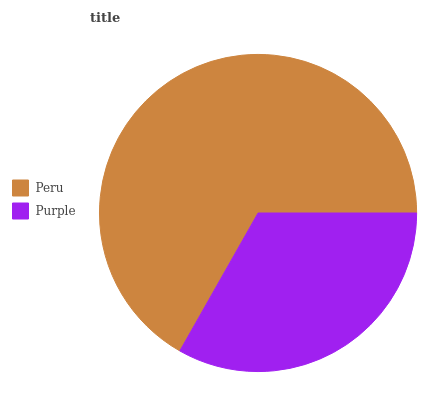Is Purple the minimum?
Answer yes or no. Yes. Is Peru the maximum?
Answer yes or no. Yes. Is Purple the maximum?
Answer yes or no. No. Is Peru greater than Purple?
Answer yes or no. Yes. Is Purple less than Peru?
Answer yes or no. Yes. Is Purple greater than Peru?
Answer yes or no. No. Is Peru less than Purple?
Answer yes or no. No. Is Peru the high median?
Answer yes or no. Yes. Is Purple the low median?
Answer yes or no. Yes. Is Purple the high median?
Answer yes or no. No. Is Peru the low median?
Answer yes or no. No. 